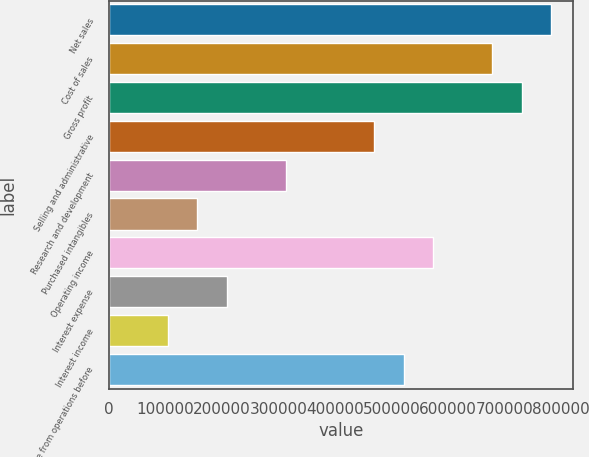Convert chart. <chart><loc_0><loc_0><loc_500><loc_500><bar_chart><fcel>Net sales<fcel>Cost of sales<fcel>Gross profit<fcel>Selling and administrative<fcel>Research and development<fcel>Purchased intangibles<fcel>Operating income<fcel>Interest expense<fcel>Interest income<fcel>Income from operations before<nl><fcel>782648<fcel>678295<fcel>730472<fcel>469590<fcel>313060<fcel>156531<fcel>573942<fcel>208708<fcel>104355<fcel>521766<nl></chart> 